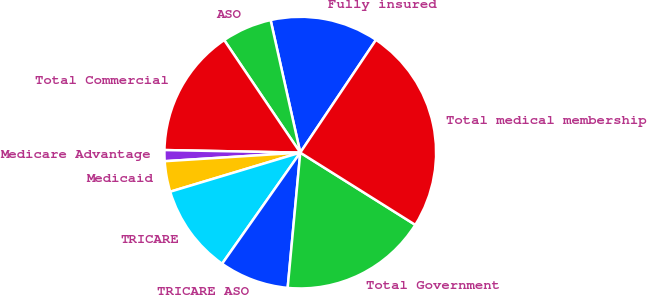Convert chart to OTSL. <chart><loc_0><loc_0><loc_500><loc_500><pie_chart><fcel>Fully insured<fcel>ASO<fcel>Total Commercial<fcel>Medicare Advantage<fcel>Medicaid<fcel>TRICARE<fcel>TRICARE ASO<fcel>Total Government<fcel>Total medical membership<nl><fcel>12.92%<fcel>5.96%<fcel>15.24%<fcel>1.31%<fcel>3.64%<fcel>10.6%<fcel>8.28%<fcel>17.56%<fcel>24.52%<nl></chart> 